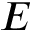<formula> <loc_0><loc_0><loc_500><loc_500>E</formula> 